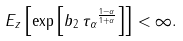Convert formula to latex. <formula><loc_0><loc_0><loc_500><loc_500>E _ { z } \left [ \exp \left [ { b _ { 2 } \, { \tau _ { \alpha } } ^ { \frac { 1 - \alpha } { 1 + \alpha } } } \right ] \right ] < \infty .</formula> 